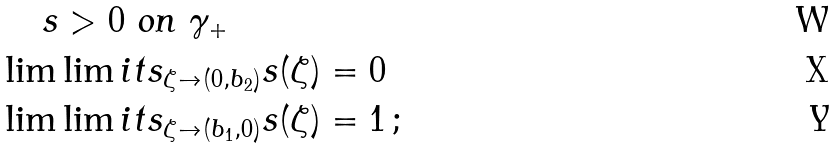<formula> <loc_0><loc_0><loc_500><loc_500>& \quad \, s > 0 \text { on } \gamma _ { + } \\ & \lim \lim i t s _ { \zeta \to ( 0 , b _ { 2 } ) } s ( \zeta ) = 0 \, \\ & \lim \lim i t s _ { \zeta \to ( b _ { 1 } , 0 ) } s ( \zeta ) = 1 \, ;</formula> 